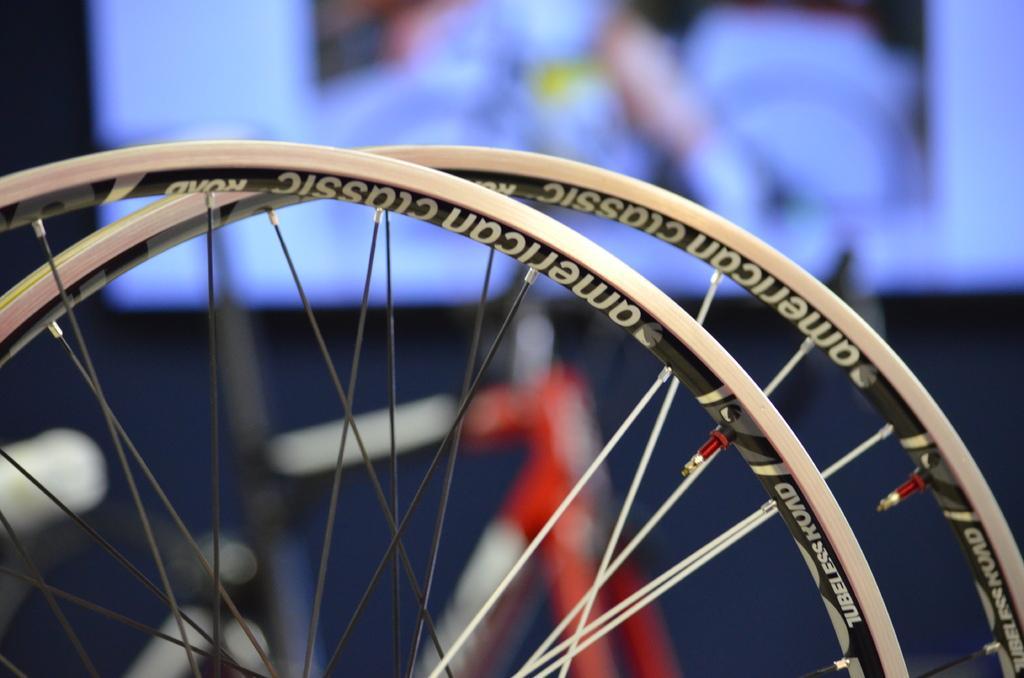Please provide a concise description of this image. In the image in the center, we can see two cycle tires and we can see something written on it. In the background there is a screen. 